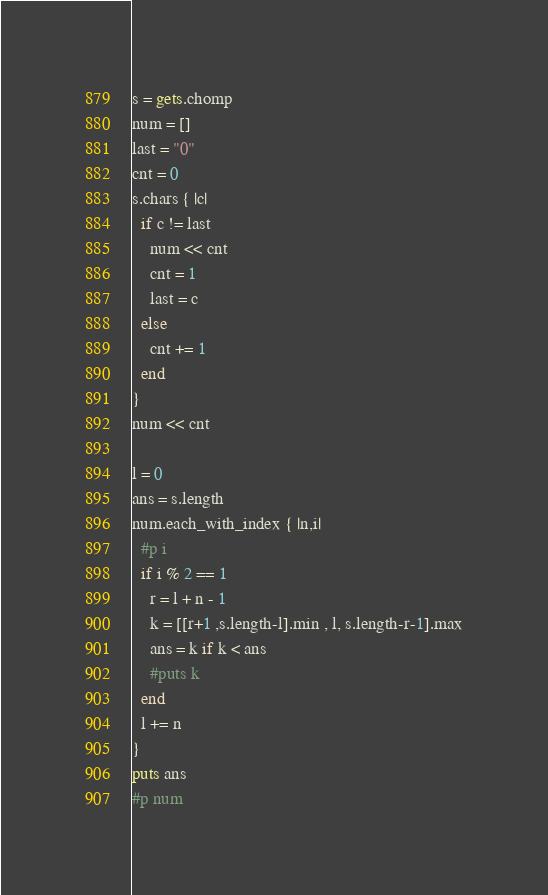<code> <loc_0><loc_0><loc_500><loc_500><_Ruby_>s = gets.chomp
num = []
last = "0"
cnt = 0
s.chars { |c|
  if c != last
    num << cnt
    cnt = 1
    last = c
  else
    cnt += 1
  end
}
num << cnt

l = 0
ans = s.length
num.each_with_index { |n,i|
  #p i
  if i % 2 == 1
    r = l + n - 1
    k = [[r+1 ,s.length-l].min , l, s.length-r-1].max
    ans = k if k < ans
    #puts k
  end
  l += n
}
puts ans
#p num
</code> 